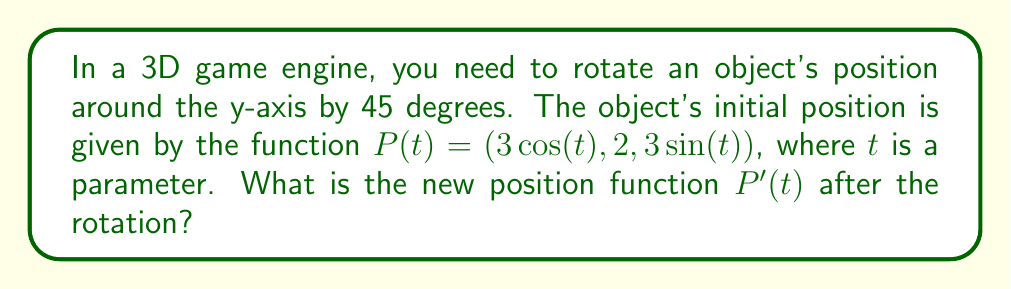Could you help me with this problem? To rotate a 3D object's position function around the y-axis, we need to apply a rotation matrix. Here's how we can solve this step-by-step:

1. The rotation matrix for a counterclockwise rotation around the y-axis by an angle $\theta$ is:

   $$R_y(\theta) = \begin{pmatrix}
   \cos(\theta) & 0 & \sin(\theta) \\
   0 & 1 & 0 \\
   -\sin(\theta) & 0 & \cos(\theta)
   \end{pmatrix}$$

2. In this case, $\theta = 45° = \frac{\pi}{4}$ radians.

3. We need to multiply this matrix by our position vector:

   $$P'(t) = R_y(\frac{\pi}{4}) \cdot P(t)$$

4. Let's perform the matrix multiplication:

   $$\begin{pmatrix}
   \cos(\frac{\pi}{4}) & 0 & \sin(\frac{\pi}{4}) \\
   0 & 1 & 0 \\
   -\sin(\frac{\pi}{4}) & 0 & \cos(\frac{\pi}{4})
   \end{pmatrix} \cdot \begin{pmatrix}
   3\cos(t) \\
   2 \\
   3\sin(t)
   \end{pmatrix}$$

5. Simplify, knowing that $\cos(\frac{\pi}{4}) = \sin(\frac{\pi}{4}) = \frac{\sqrt{2}}{2}$:

   $$\begin{pmatrix}
   \frac{\sqrt{2}}{2} \cdot 3\cos(t) + \frac{\sqrt{2}}{2} \cdot 3\sin(t) \\
   2 \\
   -\frac{\sqrt{2}}{2} \cdot 3\cos(t) + \frac{\sqrt{2}}{2} \cdot 3\sin(t)
   \end{pmatrix}$$

6. Simplify further:

   $$\begin{pmatrix}
   \frac{3\sqrt{2}}{2}(\cos(t) + \sin(t)) \\
   2 \\
   \frac{3\sqrt{2}}{2}(-\cos(t) + \sin(t))
   \end{pmatrix}$$

This gives us the new position function $P'(t)$ after rotation.
Answer: $P'(t) = (\frac{3\sqrt{2}}{2}(\cos(t) + \sin(t)), 2, \frac{3\sqrt{2}}{2}(-\cos(t) + \sin(t)))$ 